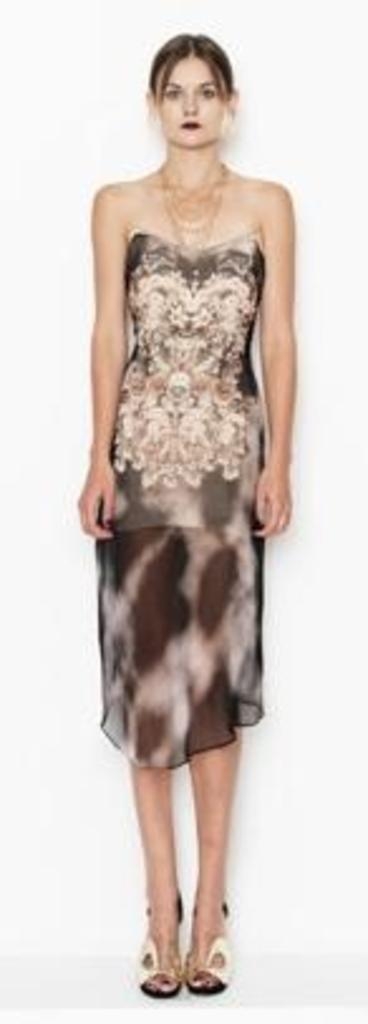What is the main subject of the image? There is a woman in the image. What is the woman doing in the image? The woman is standing. What is the woman wearing in the image? The woman is wearing a dress, a necklace, and sandals. What can be observed about the background of the image? The background of the image appears to be white in color. Can you see any fairies flying around the woman in the image? No, there are no fairies present in the image. What type of zebra can be seen in the background of the image? There is no zebra present in the image; the background appears to be white in color. 